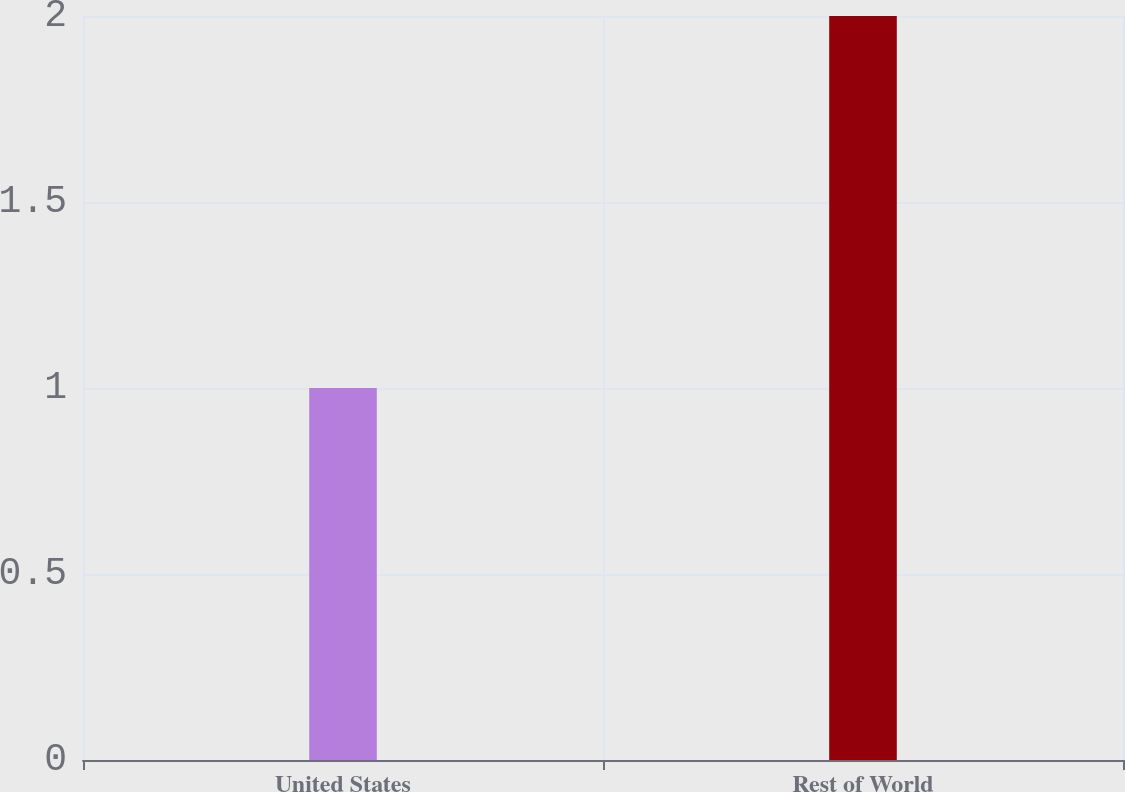Convert chart. <chart><loc_0><loc_0><loc_500><loc_500><bar_chart><fcel>United States<fcel>Rest of World<nl><fcel>1<fcel>2<nl></chart> 